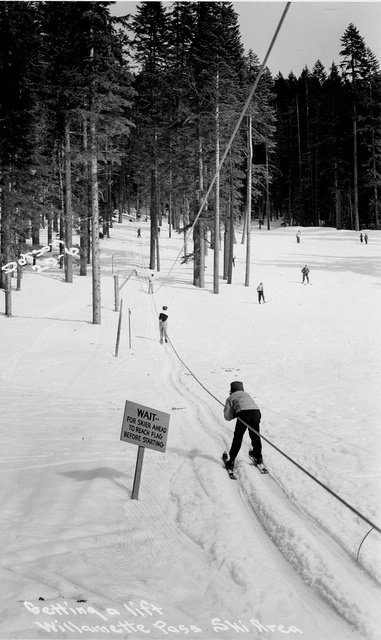Describe the objects in this image and their specific colors. I can see people in silver, black, darkgray, gray, and lightgray tones, people in lightgray, darkgray, gray, and black tones, skis in lightgray, black, gray, and darkgray tones, people in lightgray, darkgray, black, and dimgray tones, and people in lightgray, darkgray, gray, and black tones in this image. 